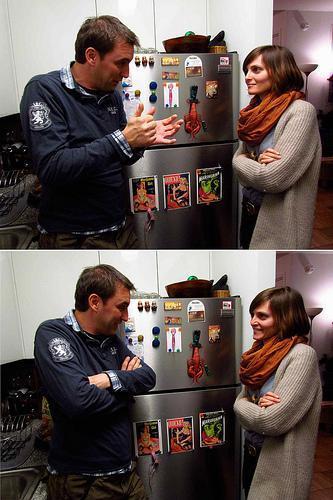How many people are in the photo?
Give a very brief answer. 2. How many people are visible?
Give a very brief answer. 2. 